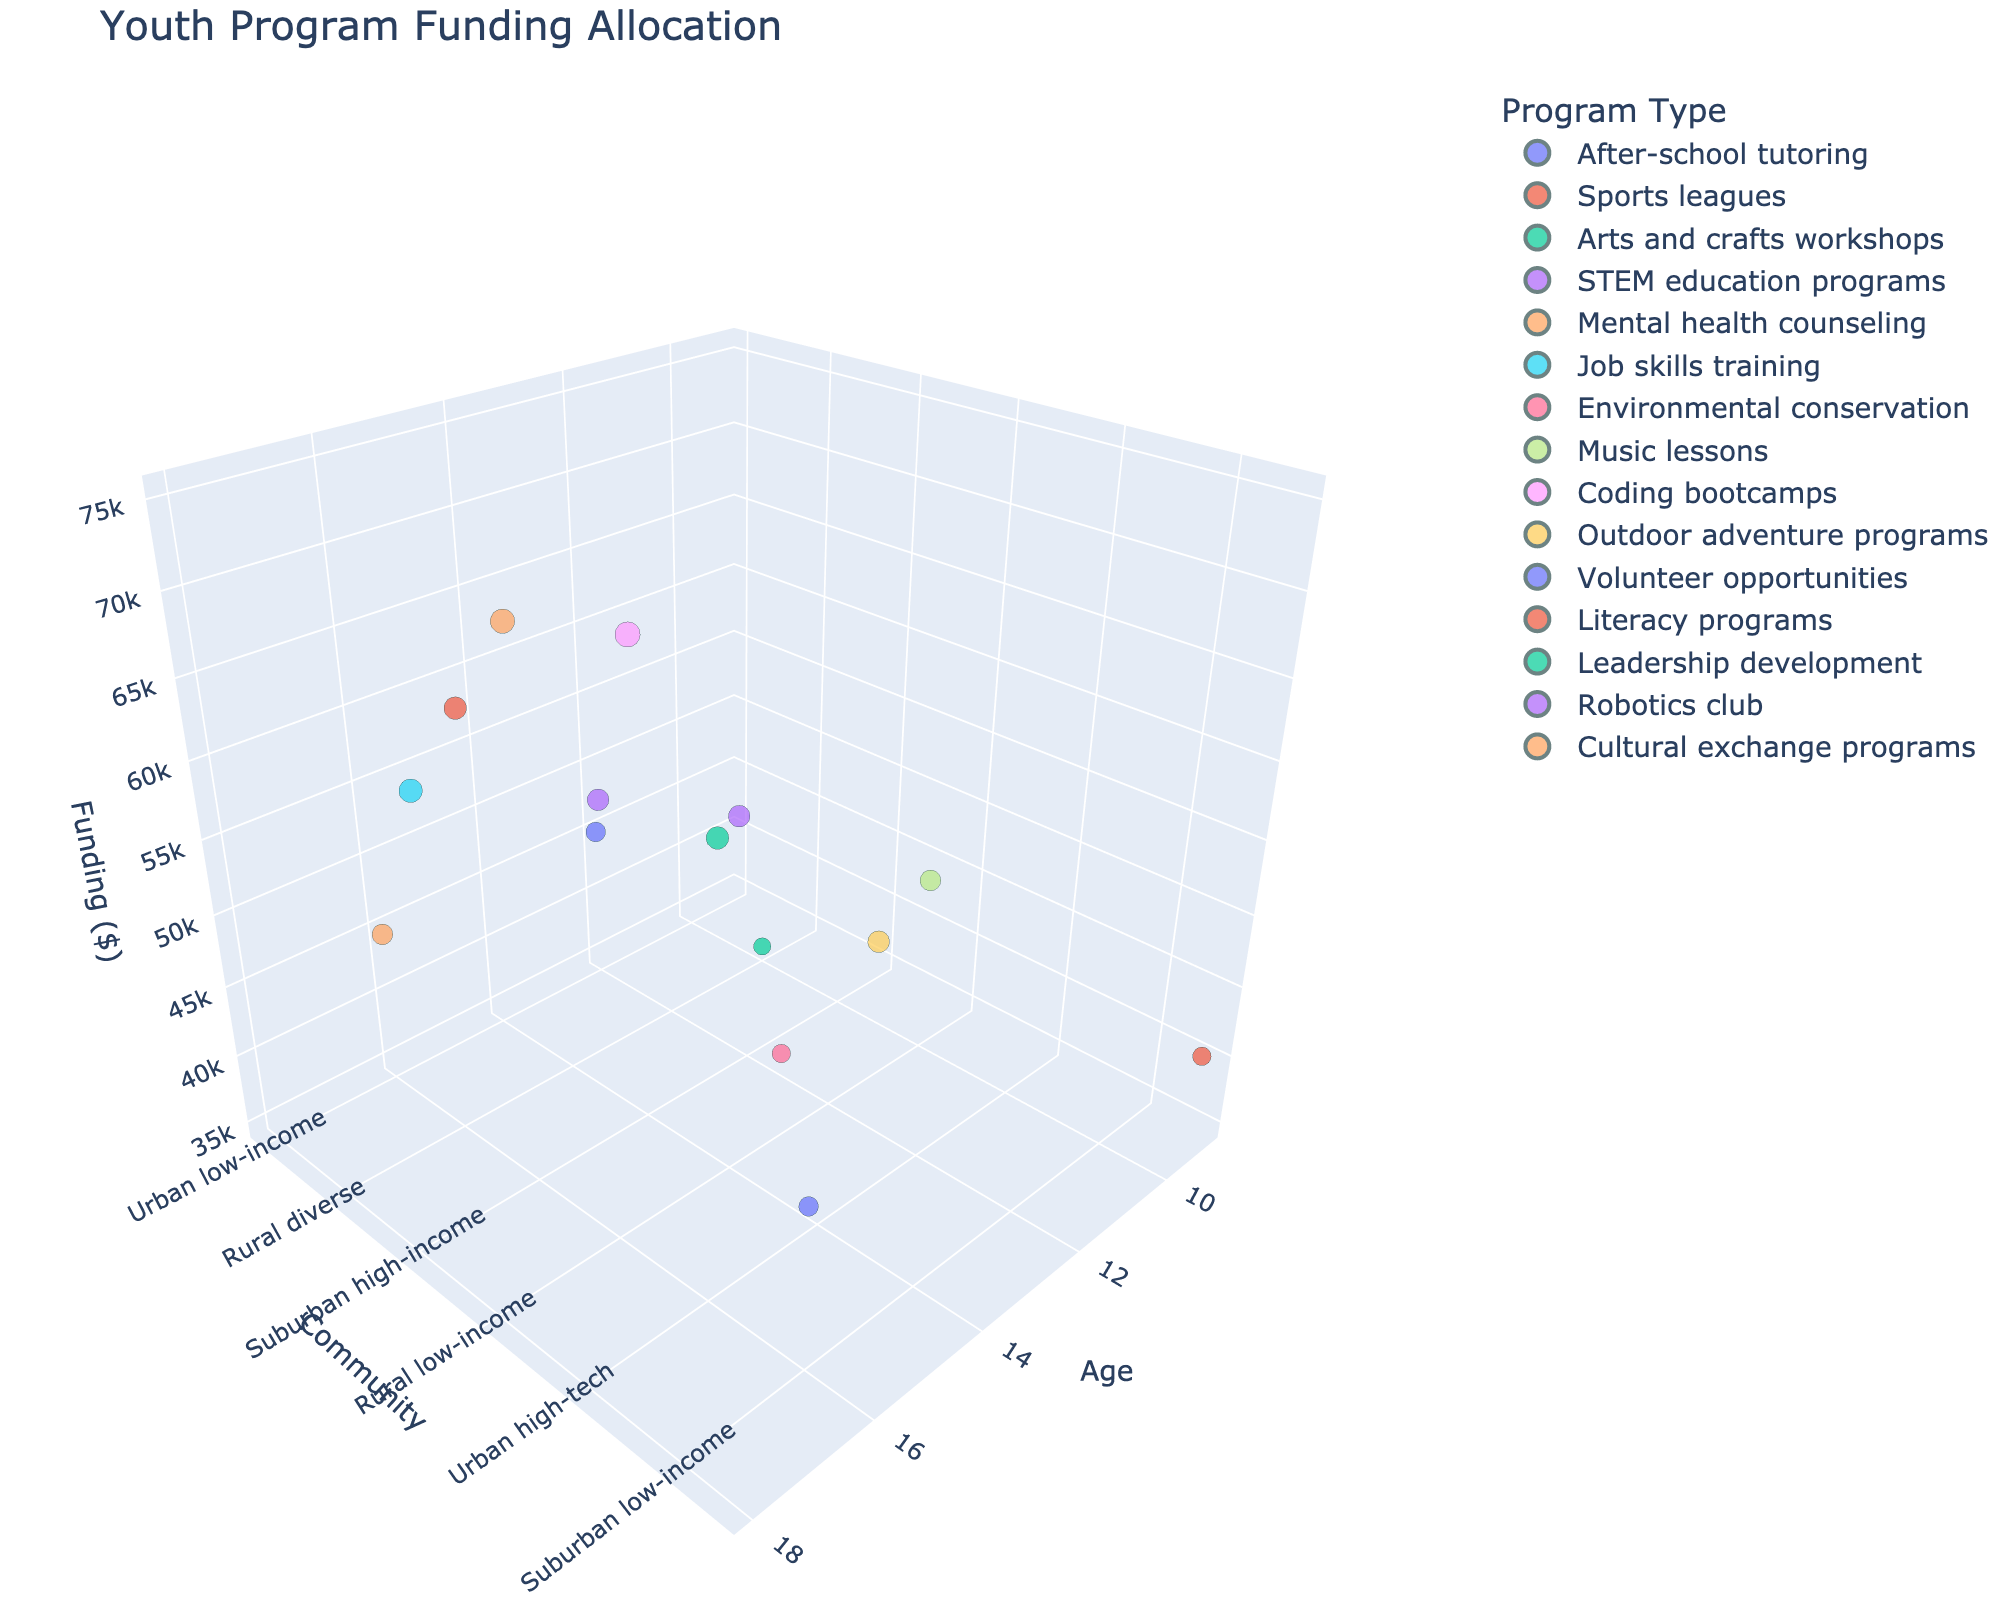what is the highest funding allocation shown on the plot? Look at the z-axis (Funding Allocation). Identify the highest point and check its value using the hover text.
Answer: 75000 Which community demographic has the highest concentration of funding allocations between 40,000 and 60,000 dollars? Scan the plots along the y-axis (Community Demographics) and check where most of the points fall within the 40,000 to 60,000 range on the z-axis (Funding Allocation).
Answer: Urban middle-class How does the funding allocation for mental health counseling compare to job skills training? Find points for both 'Mental health counseling' and 'Job skills training' and compare their heights along the z-axis (Funding Allocation).
Answer: Mental health counseling has less funding than job skills training What is the average participant age for programs with funding allocations greater than $50,000? Identify all points with funding allocations greater than 50,000 using the z-axis. Note the corresponding 'Participant Age' values and calculate their average. Detailed steps: ages for funding > 50,000 are 15, 14, 16, 18, 17, 14. Sum = 94, count = 6. Average = 94/6.
Answer: 15.67 Which program type focusing on participant age 12 is present, and what is its funding allocation? Locate the point at Participant Age 12 along the x-axis and check its hover text for program type and funding allocation.
Answer: After-school tutoring, 45000 Compare the funding allocation for urban high-tech programs to suburban low-income programs. Which receives more funding? Find points for 'Urban high-tech' and 'Suburban low-income' along the y-axis. Compare their heights on the z-axis (Funding Allocations).
Answer: Urban high-tech programs receive more funding What is the range of funding allocations for urban middle-class community demographics? Find all points along the y-axis for 'Urban middle-class' and note the minimum and maximum values along the z-axis.
Answer: 55000 to 65000 How many unique program types are represented in the plot? Check the legend for the 'Program Type' to count the unique entries.
Answer: 15 Which community demographic has the lowest average funding allocation, based on the visual information? Calculate the average funding allocation for each community demographic. Detailed steps: find the values on the z-axis for each demographic and compute their averages.
Answer: Urban immigrant What demographic receives funding allocation between 30,000 and 50,000 for arts and crafts workshops? Locate the point for 'Arts and crafts workshops' and check its community demographic using hover text.
Answer: Rural diverse 